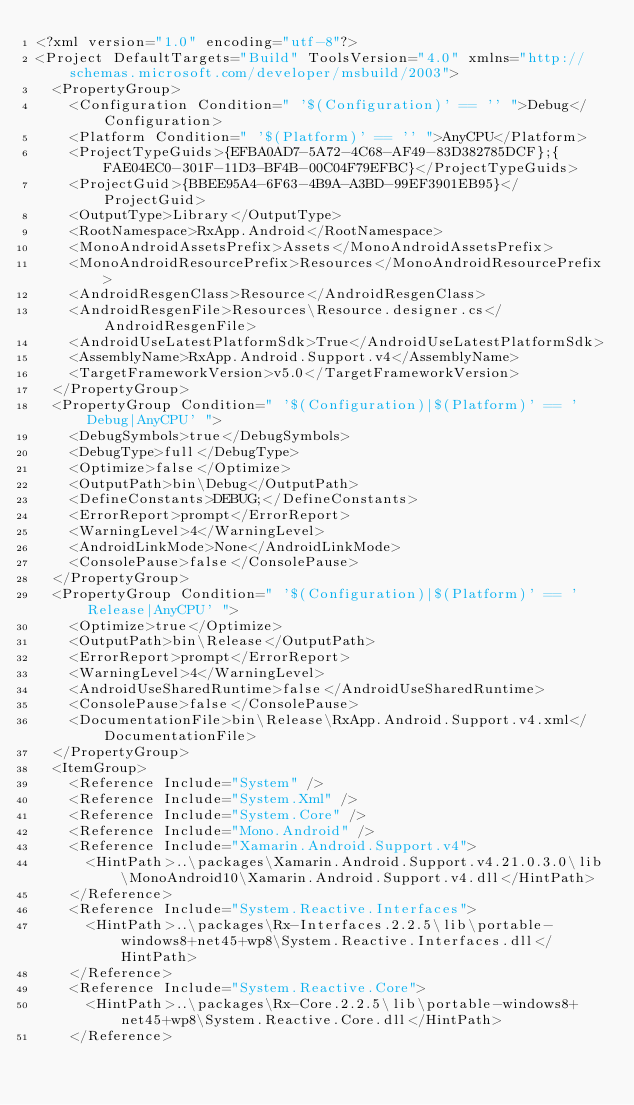Convert code to text. <code><loc_0><loc_0><loc_500><loc_500><_XML_><?xml version="1.0" encoding="utf-8"?>
<Project DefaultTargets="Build" ToolsVersion="4.0" xmlns="http://schemas.microsoft.com/developer/msbuild/2003">
  <PropertyGroup>
    <Configuration Condition=" '$(Configuration)' == '' ">Debug</Configuration>
    <Platform Condition=" '$(Platform)' == '' ">AnyCPU</Platform>
    <ProjectTypeGuids>{EFBA0AD7-5A72-4C68-AF49-83D382785DCF};{FAE04EC0-301F-11D3-BF4B-00C04F79EFBC}</ProjectTypeGuids>
    <ProjectGuid>{BBEE95A4-6F63-4B9A-A3BD-99EF3901EB95}</ProjectGuid>
    <OutputType>Library</OutputType>
    <RootNamespace>RxApp.Android</RootNamespace>
    <MonoAndroidAssetsPrefix>Assets</MonoAndroidAssetsPrefix>
    <MonoAndroidResourcePrefix>Resources</MonoAndroidResourcePrefix>
    <AndroidResgenClass>Resource</AndroidResgenClass>
    <AndroidResgenFile>Resources\Resource.designer.cs</AndroidResgenFile>
    <AndroidUseLatestPlatformSdk>True</AndroidUseLatestPlatformSdk>
    <AssemblyName>RxApp.Android.Support.v4</AssemblyName>
    <TargetFrameworkVersion>v5.0</TargetFrameworkVersion>
  </PropertyGroup>
  <PropertyGroup Condition=" '$(Configuration)|$(Platform)' == 'Debug|AnyCPU' ">
    <DebugSymbols>true</DebugSymbols>
    <DebugType>full</DebugType>
    <Optimize>false</Optimize>
    <OutputPath>bin\Debug</OutputPath>
    <DefineConstants>DEBUG;</DefineConstants>
    <ErrorReport>prompt</ErrorReport>
    <WarningLevel>4</WarningLevel>
    <AndroidLinkMode>None</AndroidLinkMode>
    <ConsolePause>false</ConsolePause>
  </PropertyGroup>
  <PropertyGroup Condition=" '$(Configuration)|$(Platform)' == 'Release|AnyCPU' ">
    <Optimize>true</Optimize>
    <OutputPath>bin\Release</OutputPath>
    <ErrorReport>prompt</ErrorReport>
    <WarningLevel>4</WarningLevel>
    <AndroidUseSharedRuntime>false</AndroidUseSharedRuntime>
    <ConsolePause>false</ConsolePause>
    <DocumentationFile>bin\Release\RxApp.Android.Support.v4.xml</DocumentationFile>
  </PropertyGroup>
  <ItemGroup>
    <Reference Include="System" />
    <Reference Include="System.Xml" />
    <Reference Include="System.Core" />
    <Reference Include="Mono.Android" />
    <Reference Include="Xamarin.Android.Support.v4">
      <HintPath>..\packages\Xamarin.Android.Support.v4.21.0.3.0\lib\MonoAndroid10\Xamarin.Android.Support.v4.dll</HintPath>
    </Reference>
    <Reference Include="System.Reactive.Interfaces">
      <HintPath>..\packages\Rx-Interfaces.2.2.5\lib\portable-windows8+net45+wp8\System.Reactive.Interfaces.dll</HintPath>
    </Reference>
    <Reference Include="System.Reactive.Core">
      <HintPath>..\packages\Rx-Core.2.2.5\lib\portable-windows8+net45+wp8\System.Reactive.Core.dll</HintPath>
    </Reference></code> 